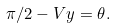Convert formula to latex. <formula><loc_0><loc_0><loc_500><loc_500>\pi / 2 - V y = \theta .</formula> 